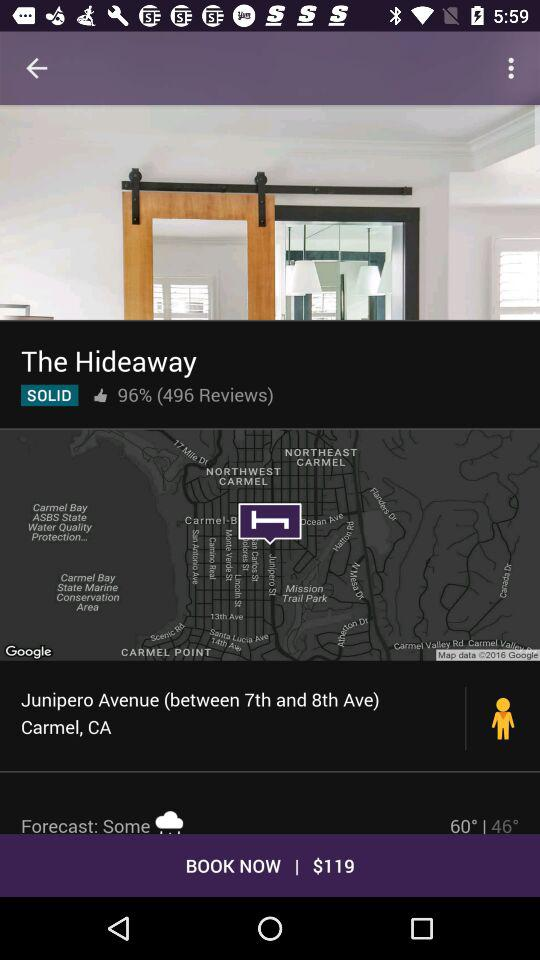How many degrees is the temperature difference between the high and low?
Answer the question using a single word or phrase. 14 